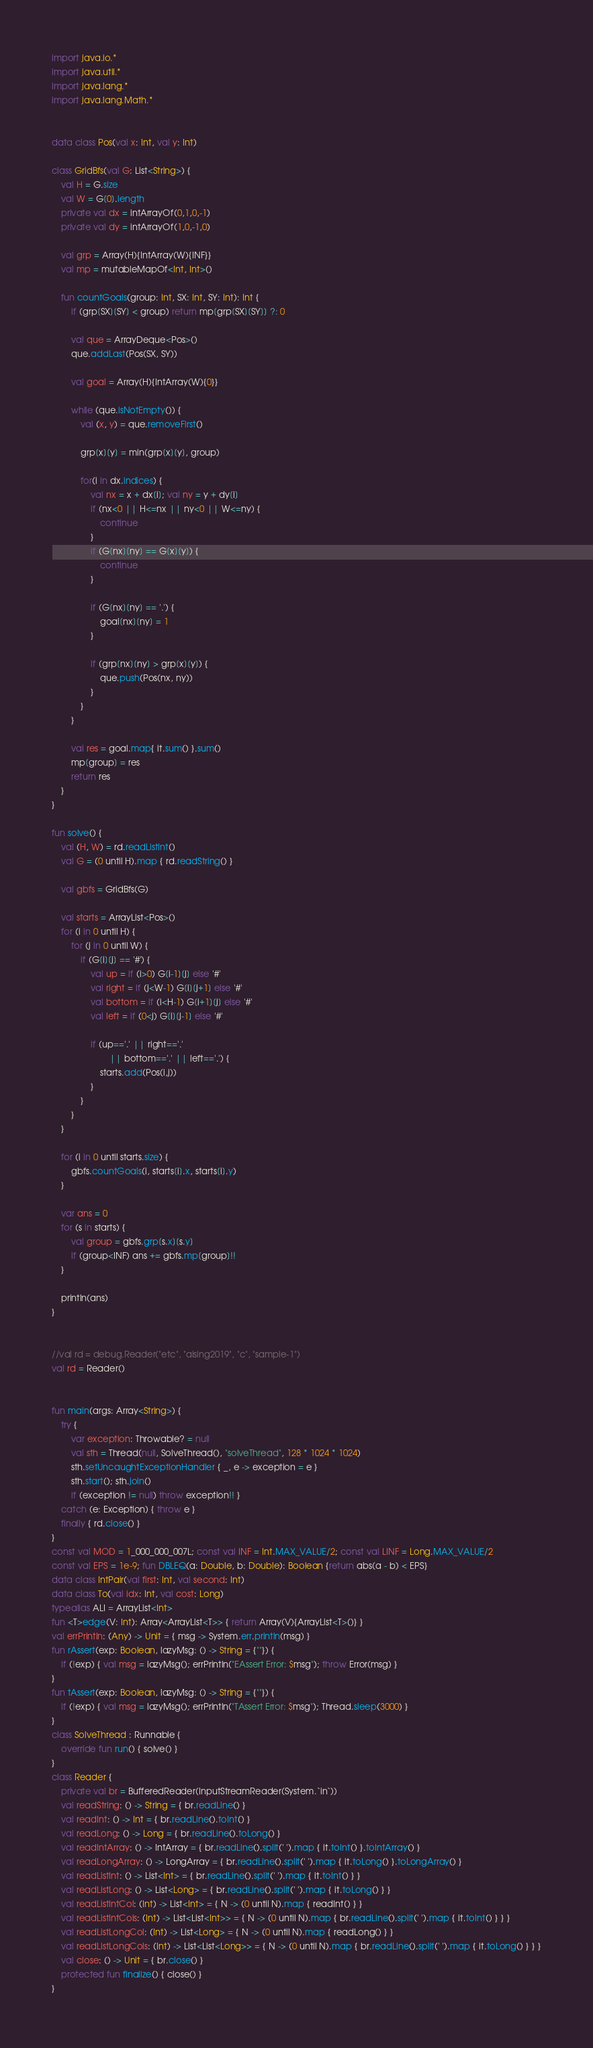Convert code to text. <code><loc_0><loc_0><loc_500><loc_500><_Kotlin_>import java.io.*
import java.util.*
import java.lang.*
import java.lang.Math.*


data class Pos(val x: Int, val y: Int)

class GridBfs(val G: List<String>) {
    val H = G.size
    val W = G[0].length
    private val dx = intArrayOf(0,1,0,-1)
    private val dy = intArrayOf(1,0,-1,0)

    val grp = Array(H){IntArray(W){INF}}
    val mp = mutableMapOf<Int, Int>()

    fun countGoals(group: Int, SX: Int, SY: Int): Int {
        if (grp[SX][SY] < group) return mp[grp[SX][SY]] ?: 0

        val que = ArrayDeque<Pos>()
        que.addLast(Pos(SX, SY))

        val goal = Array(H){IntArray(W){0}}

        while (que.isNotEmpty()) {
            val (x, y) = que.removeFirst()

            grp[x][y] = min(grp[x][y], group)

            for(i in dx.indices) {
                val nx = x + dx[i]; val ny = y + dy[i]
                if (nx<0 || H<=nx || ny<0 || W<=ny) {
                    continue
                }
                if (G[nx][ny] == G[x][y]) {
                    continue
                }

                if (G[nx][ny] == '.') {
                    goal[nx][ny] = 1
                }

                if (grp[nx][ny] > grp[x][y]) {
                    que.push(Pos(nx, ny))
                }
            }
        }

        val res = goal.map{ it.sum() }.sum()
        mp[group] = res
        return res
    }
}

fun solve() {
    val (H, W) = rd.readListInt()
    val G = (0 until H).map { rd.readString() }

    val gbfs = GridBfs(G)

    val starts = ArrayList<Pos>()
    for (i in 0 until H) {
        for (j in 0 until W) {
            if (G[i][j] == '#') {
                val up = if (i>0) G[i-1][j] else '#'
                val right = if (j<W-1) G[i][j+1] else '#'
                val bottom = if (i<H-1) G[i+1][j] else '#'
                val left = if (0<j) G[i][j-1] else '#'

                if (up=='.' || right=='.'
                        || bottom=='.' || left=='.') {
                    starts.add(Pos(i,j))
                }
            }
        }
    }

    for (i in 0 until starts.size) {
        gbfs.countGoals(i, starts[i].x, starts[i].y)
    }

    var ans = 0
    for (s in starts) {
        val group = gbfs.grp[s.x][s.y]
        if (group<INF) ans += gbfs.mp[group]!!
    }

    println(ans)
}


//val rd = debug.Reader("etc", "aising2019", "c", "sample-1")
val rd = Reader()


fun main(args: Array<String>) {
    try {
        var exception: Throwable? = null
        val sth = Thread(null, SolveThread(), "solveThread", 128 * 1024 * 1024)
        sth.setUncaughtExceptionHandler { _, e -> exception = e }
        sth.start(); sth.join()
        if (exception != null) throw exception!! }
    catch (e: Exception) { throw e }
    finally { rd.close() }
}
const val MOD = 1_000_000_007L; const val INF = Int.MAX_VALUE/2; const val LINF = Long.MAX_VALUE/2
const val EPS = 1e-9; fun DBLEQ(a: Double, b: Double): Boolean {return abs(a - b) < EPS}
data class IntPair(val first: Int, val second: Int)
data class To(val idx: Int, val cost: Long)
typealias ALI = ArrayList<Int>
fun <T>edge(V: Int): Array<ArrayList<T>> { return Array(V){ArrayList<T>()} }
val errPrintln: (Any) -> Unit = { msg -> System.err.println(msg) }
fun rAssert(exp: Boolean, lazyMsg: () -> String = {""}) {
    if (!exp) { val msg = lazyMsg(); errPrintln("EAssert Error: $msg"); throw Error(msg) }
}
fun tAssert(exp: Boolean, lazyMsg: () -> String = {""}) {
    if (!exp) { val msg = lazyMsg(); errPrintln("TAssert Error: $msg"); Thread.sleep(3000) }
}
class SolveThread : Runnable {
    override fun run() { solve() }
}
class Reader {
    private val br = BufferedReader(InputStreamReader(System.`in`))
    val readString: () -> String = { br.readLine() }
    val readInt: () -> Int = { br.readLine().toInt() }
    val readLong: () -> Long = { br.readLine().toLong() }
    val readIntArray: () -> IntArray = { br.readLine().split(' ').map { it.toInt() }.toIntArray() }
    val readLongArray: () -> LongArray = { br.readLine().split(' ').map { it.toLong() }.toLongArray() }
    val readListInt: () -> List<Int> = { br.readLine().split(' ').map { it.toInt() } }
    val readListLong: () -> List<Long> = { br.readLine().split(' ').map { it.toLong() } }
    val readListIntCol: (Int) -> List<Int> = { N -> (0 until N).map { readInt() } }
    val readListIntCols: (Int) -> List<List<Int>> = { N -> (0 until N).map { br.readLine().split(' ').map { it.toInt() } } }
    val readListLongCol: (Int) -> List<Long> = { N -> (0 until N).map { readLong() } }
    val readListLongCols: (Int) -> List<List<Long>> = { N -> (0 until N).map { br.readLine().split(' ').map { it.toLong() } } }
    val close: () -> Unit = { br.close() }
    protected fun finalize() { close() }
}
</code> 